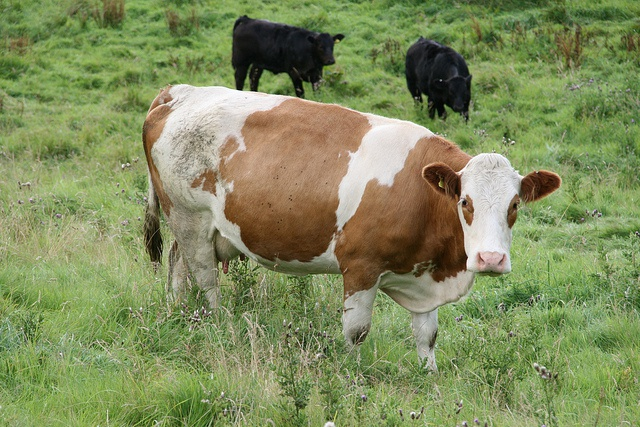Describe the objects in this image and their specific colors. I can see cow in green, lightgray, tan, darkgray, and gray tones, cow in green, black, gray, olive, and darkgreen tones, and cow in green, black, gray, darkgreen, and olive tones in this image. 